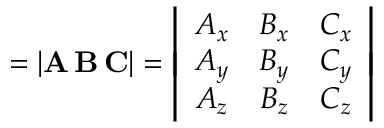<formula> <loc_0><loc_0><loc_500><loc_500>= | A \, B \, C | = \left | { \begin{array} { c c c } { A _ { x } } & { B _ { x } } & { C _ { x } } \\ { A _ { y } } & { B _ { y } } & { C _ { y } } \\ { A _ { z } } & { B _ { z } } & { C _ { z } } \end{array} } \right |</formula> 